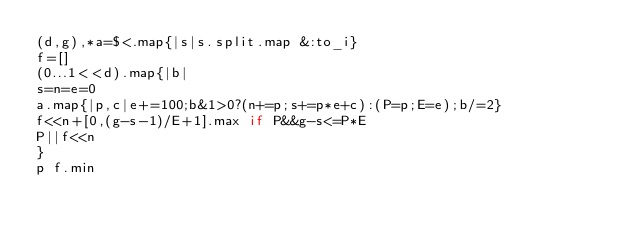<code> <loc_0><loc_0><loc_500><loc_500><_Ruby_>(d,g),*a=$<.map{|s|s.split.map &:to_i}
f=[]
(0...1<<d).map{|b|
s=n=e=0
a.map{|p,c|e+=100;b&1>0?(n+=p;s+=p*e+c):(P=p;E=e);b/=2}
f<<n+[0,(g-s-1)/E+1].max if P&&g-s<=P*E
P||f<<n
}
p f.min
</code> 